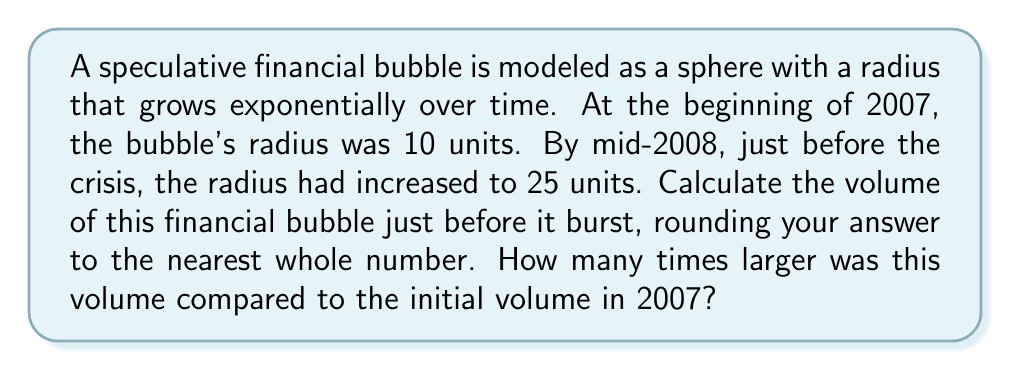Could you help me with this problem? Let's approach this step-by-step:

1) The volume of a sphere is given by the formula:
   $$V = \frac{4}{3}\pi r^3$$

2) For the initial volume in 2007 (radius = 10 units):
   $$V_{2007} = \frac{4}{3}\pi (10)^3 = \frac{4000\pi}{3} \approx 4188.79$$

3) For the volume just before bursting in 2008 (radius = 25 units):
   $$V_{2008} = \frac{4}{3}\pi (25)^3 = \frac{62500\pi}{3} \approx 65449.85$$

4) Rounding $V_{2008}$ to the nearest whole number:
   $$V_{2008} \approx 65450$$

5) To find how many times larger the 2008 volume was:
   $$\text{Ratio} = \frac{V_{2008}}{V_{2007}} = \frac{65449.85}{4188.79} \approx 15.625$$

This ratio shows that the volume in 2008 was about 15.625 times larger than in 2007, reflecting the rapid and unsustainable growth of the financial bubble before it burst.
Answer: 65450 cubic units; 15.625 times larger 